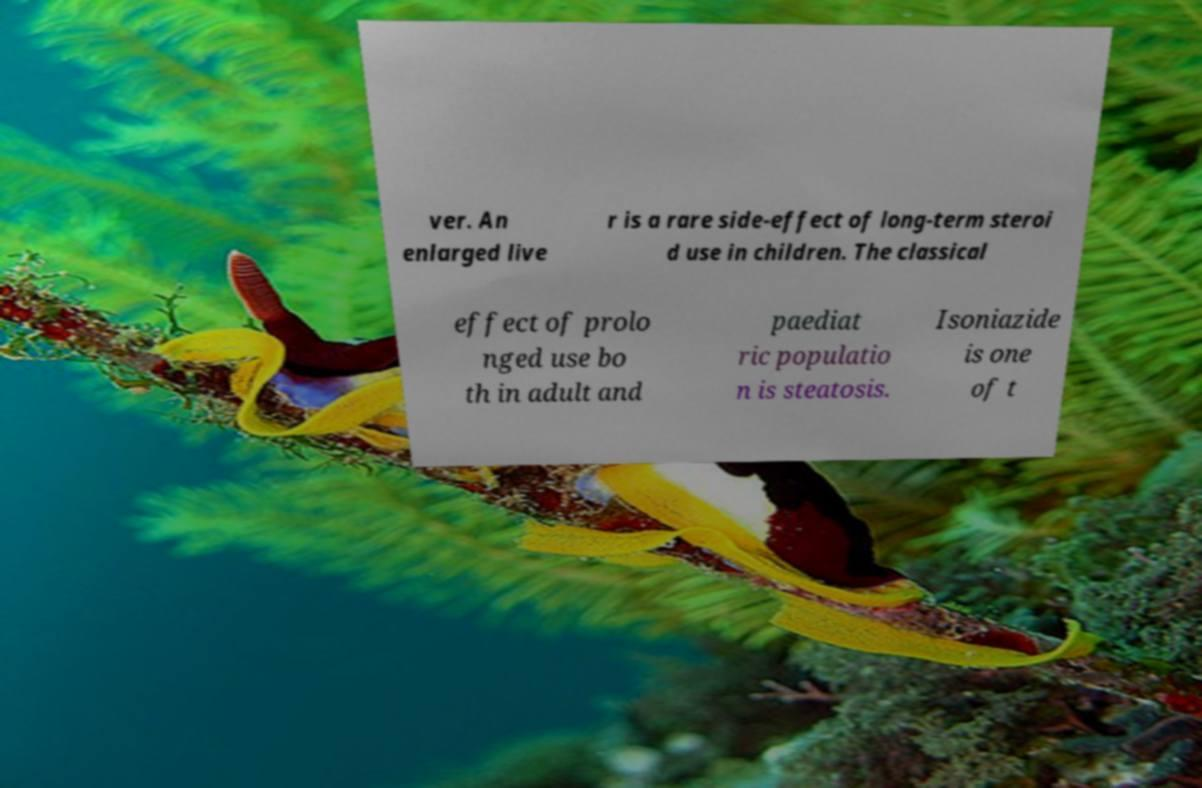I need the written content from this picture converted into text. Can you do that? ver. An enlarged live r is a rare side-effect of long-term steroi d use in children. The classical effect of prolo nged use bo th in adult and paediat ric populatio n is steatosis. Isoniazide is one of t 